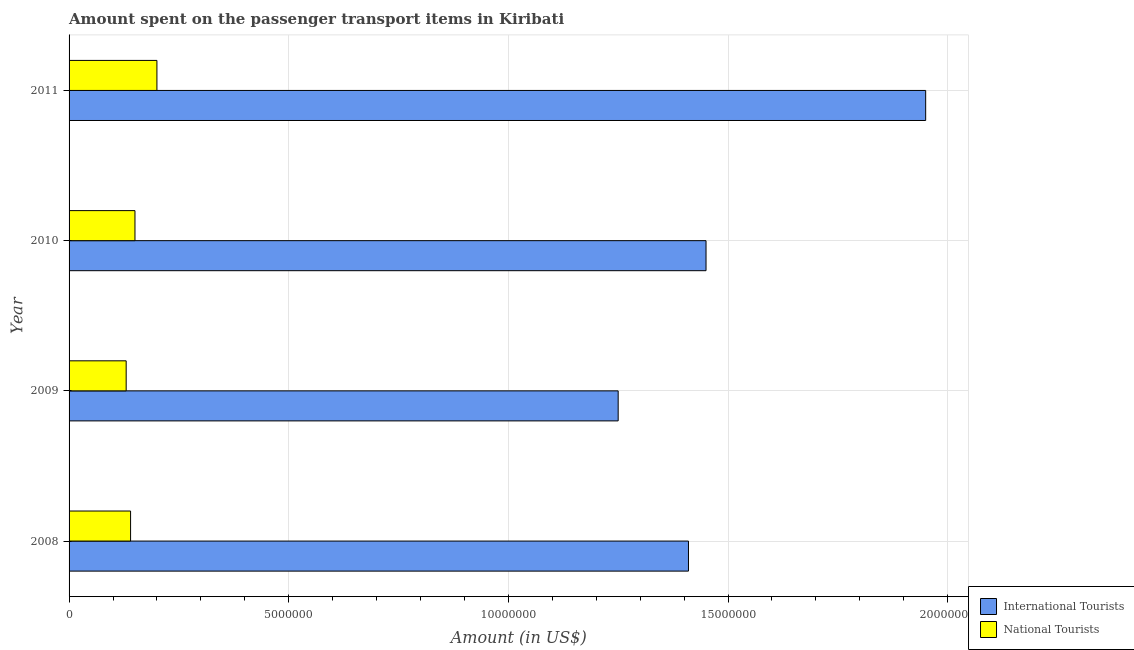How many different coloured bars are there?
Your response must be concise. 2. How many groups of bars are there?
Your response must be concise. 4. What is the label of the 2nd group of bars from the top?
Your answer should be compact. 2010. In how many cases, is the number of bars for a given year not equal to the number of legend labels?
Provide a succinct answer. 0. What is the amount spent on transport items of national tourists in 2010?
Ensure brevity in your answer.  1.50e+06. Across all years, what is the maximum amount spent on transport items of international tourists?
Offer a terse response. 1.95e+07. Across all years, what is the minimum amount spent on transport items of international tourists?
Offer a terse response. 1.25e+07. In which year was the amount spent on transport items of national tourists maximum?
Your answer should be compact. 2011. In which year was the amount spent on transport items of international tourists minimum?
Offer a terse response. 2009. What is the total amount spent on transport items of international tourists in the graph?
Your answer should be compact. 6.06e+07. What is the difference between the amount spent on transport items of international tourists in 2009 and that in 2010?
Make the answer very short. -2.00e+06. What is the difference between the amount spent on transport items of national tourists in 2009 and the amount spent on transport items of international tourists in 2010?
Provide a short and direct response. -1.32e+07. What is the average amount spent on transport items of international tourists per year?
Make the answer very short. 1.52e+07. In the year 2011, what is the difference between the amount spent on transport items of national tourists and amount spent on transport items of international tourists?
Give a very brief answer. -1.75e+07. What is the ratio of the amount spent on transport items of national tourists in 2010 to that in 2011?
Your response must be concise. 0.75. Is the difference between the amount spent on transport items of national tourists in 2010 and 2011 greater than the difference between the amount spent on transport items of international tourists in 2010 and 2011?
Give a very brief answer. Yes. What is the difference between the highest and the lowest amount spent on transport items of national tourists?
Provide a succinct answer. 7.00e+05. What does the 2nd bar from the top in 2008 represents?
Keep it short and to the point. International Tourists. What does the 2nd bar from the bottom in 2009 represents?
Provide a succinct answer. National Tourists. How many bars are there?
Make the answer very short. 8. Are all the bars in the graph horizontal?
Keep it short and to the point. Yes. What is the difference between two consecutive major ticks on the X-axis?
Your response must be concise. 5.00e+06. Are the values on the major ticks of X-axis written in scientific E-notation?
Ensure brevity in your answer.  No. Does the graph contain any zero values?
Give a very brief answer. No. Where does the legend appear in the graph?
Make the answer very short. Bottom right. How many legend labels are there?
Your response must be concise. 2. What is the title of the graph?
Give a very brief answer. Amount spent on the passenger transport items in Kiribati. What is the Amount (in US$) in International Tourists in 2008?
Offer a very short reply. 1.41e+07. What is the Amount (in US$) in National Tourists in 2008?
Offer a very short reply. 1.40e+06. What is the Amount (in US$) of International Tourists in 2009?
Offer a terse response. 1.25e+07. What is the Amount (in US$) in National Tourists in 2009?
Your answer should be very brief. 1.30e+06. What is the Amount (in US$) of International Tourists in 2010?
Offer a very short reply. 1.45e+07. What is the Amount (in US$) in National Tourists in 2010?
Provide a succinct answer. 1.50e+06. What is the Amount (in US$) in International Tourists in 2011?
Your answer should be compact. 1.95e+07. What is the Amount (in US$) of National Tourists in 2011?
Your response must be concise. 2.00e+06. Across all years, what is the maximum Amount (in US$) of International Tourists?
Provide a short and direct response. 1.95e+07. Across all years, what is the minimum Amount (in US$) of International Tourists?
Offer a terse response. 1.25e+07. Across all years, what is the minimum Amount (in US$) in National Tourists?
Offer a terse response. 1.30e+06. What is the total Amount (in US$) in International Tourists in the graph?
Ensure brevity in your answer.  6.06e+07. What is the total Amount (in US$) of National Tourists in the graph?
Your response must be concise. 6.20e+06. What is the difference between the Amount (in US$) of International Tourists in 2008 and that in 2009?
Your response must be concise. 1.60e+06. What is the difference between the Amount (in US$) of International Tourists in 2008 and that in 2010?
Your answer should be compact. -4.00e+05. What is the difference between the Amount (in US$) of International Tourists in 2008 and that in 2011?
Your response must be concise. -5.40e+06. What is the difference between the Amount (in US$) of National Tourists in 2008 and that in 2011?
Offer a very short reply. -6.00e+05. What is the difference between the Amount (in US$) in International Tourists in 2009 and that in 2010?
Make the answer very short. -2.00e+06. What is the difference between the Amount (in US$) in National Tourists in 2009 and that in 2010?
Provide a succinct answer. -2.00e+05. What is the difference between the Amount (in US$) in International Tourists in 2009 and that in 2011?
Provide a short and direct response. -7.00e+06. What is the difference between the Amount (in US$) in National Tourists in 2009 and that in 2011?
Provide a succinct answer. -7.00e+05. What is the difference between the Amount (in US$) in International Tourists in 2010 and that in 2011?
Ensure brevity in your answer.  -5.00e+06. What is the difference between the Amount (in US$) of National Tourists in 2010 and that in 2011?
Give a very brief answer. -5.00e+05. What is the difference between the Amount (in US$) in International Tourists in 2008 and the Amount (in US$) in National Tourists in 2009?
Give a very brief answer. 1.28e+07. What is the difference between the Amount (in US$) in International Tourists in 2008 and the Amount (in US$) in National Tourists in 2010?
Keep it short and to the point. 1.26e+07. What is the difference between the Amount (in US$) of International Tourists in 2008 and the Amount (in US$) of National Tourists in 2011?
Your answer should be compact. 1.21e+07. What is the difference between the Amount (in US$) in International Tourists in 2009 and the Amount (in US$) in National Tourists in 2010?
Your response must be concise. 1.10e+07. What is the difference between the Amount (in US$) in International Tourists in 2009 and the Amount (in US$) in National Tourists in 2011?
Keep it short and to the point. 1.05e+07. What is the difference between the Amount (in US$) of International Tourists in 2010 and the Amount (in US$) of National Tourists in 2011?
Provide a succinct answer. 1.25e+07. What is the average Amount (in US$) of International Tourists per year?
Your answer should be very brief. 1.52e+07. What is the average Amount (in US$) of National Tourists per year?
Your answer should be very brief. 1.55e+06. In the year 2008, what is the difference between the Amount (in US$) in International Tourists and Amount (in US$) in National Tourists?
Ensure brevity in your answer.  1.27e+07. In the year 2009, what is the difference between the Amount (in US$) of International Tourists and Amount (in US$) of National Tourists?
Make the answer very short. 1.12e+07. In the year 2010, what is the difference between the Amount (in US$) of International Tourists and Amount (in US$) of National Tourists?
Provide a short and direct response. 1.30e+07. In the year 2011, what is the difference between the Amount (in US$) in International Tourists and Amount (in US$) in National Tourists?
Your answer should be very brief. 1.75e+07. What is the ratio of the Amount (in US$) in International Tourists in 2008 to that in 2009?
Offer a terse response. 1.13. What is the ratio of the Amount (in US$) of International Tourists in 2008 to that in 2010?
Provide a short and direct response. 0.97. What is the ratio of the Amount (in US$) in International Tourists in 2008 to that in 2011?
Ensure brevity in your answer.  0.72. What is the ratio of the Amount (in US$) in National Tourists in 2008 to that in 2011?
Provide a short and direct response. 0.7. What is the ratio of the Amount (in US$) in International Tourists in 2009 to that in 2010?
Make the answer very short. 0.86. What is the ratio of the Amount (in US$) of National Tourists in 2009 to that in 2010?
Provide a short and direct response. 0.87. What is the ratio of the Amount (in US$) of International Tourists in 2009 to that in 2011?
Your response must be concise. 0.64. What is the ratio of the Amount (in US$) of National Tourists in 2009 to that in 2011?
Offer a very short reply. 0.65. What is the ratio of the Amount (in US$) in International Tourists in 2010 to that in 2011?
Your answer should be compact. 0.74. What is the ratio of the Amount (in US$) in National Tourists in 2010 to that in 2011?
Ensure brevity in your answer.  0.75. What is the difference between the highest and the lowest Amount (in US$) in International Tourists?
Give a very brief answer. 7.00e+06. What is the difference between the highest and the lowest Amount (in US$) of National Tourists?
Keep it short and to the point. 7.00e+05. 